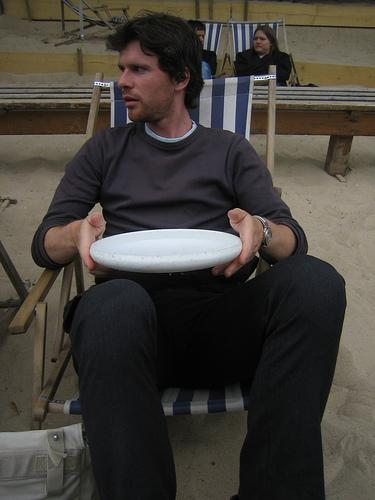What outdoor activity has the man taken a break from? Please explain your reasoning. frisbee. He is holding a plastic disk in his hands 